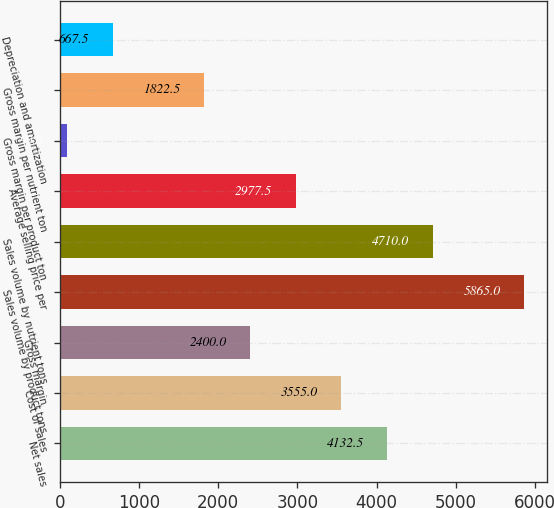Convert chart. <chart><loc_0><loc_0><loc_500><loc_500><bar_chart><fcel>Net sales<fcel>Cost of sales<fcel>Gross margin<fcel>Sales volume by product tons<fcel>Sales volume by nutrient tons<fcel>Average selling price per<fcel>Gross margin per product ton<fcel>Gross margin per nutrient ton<fcel>Depreciation and amortization<nl><fcel>4132.5<fcel>3555<fcel>2400<fcel>5865<fcel>4710<fcel>2977.5<fcel>90<fcel>1822.5<fcel>667.5<nl></chart> 